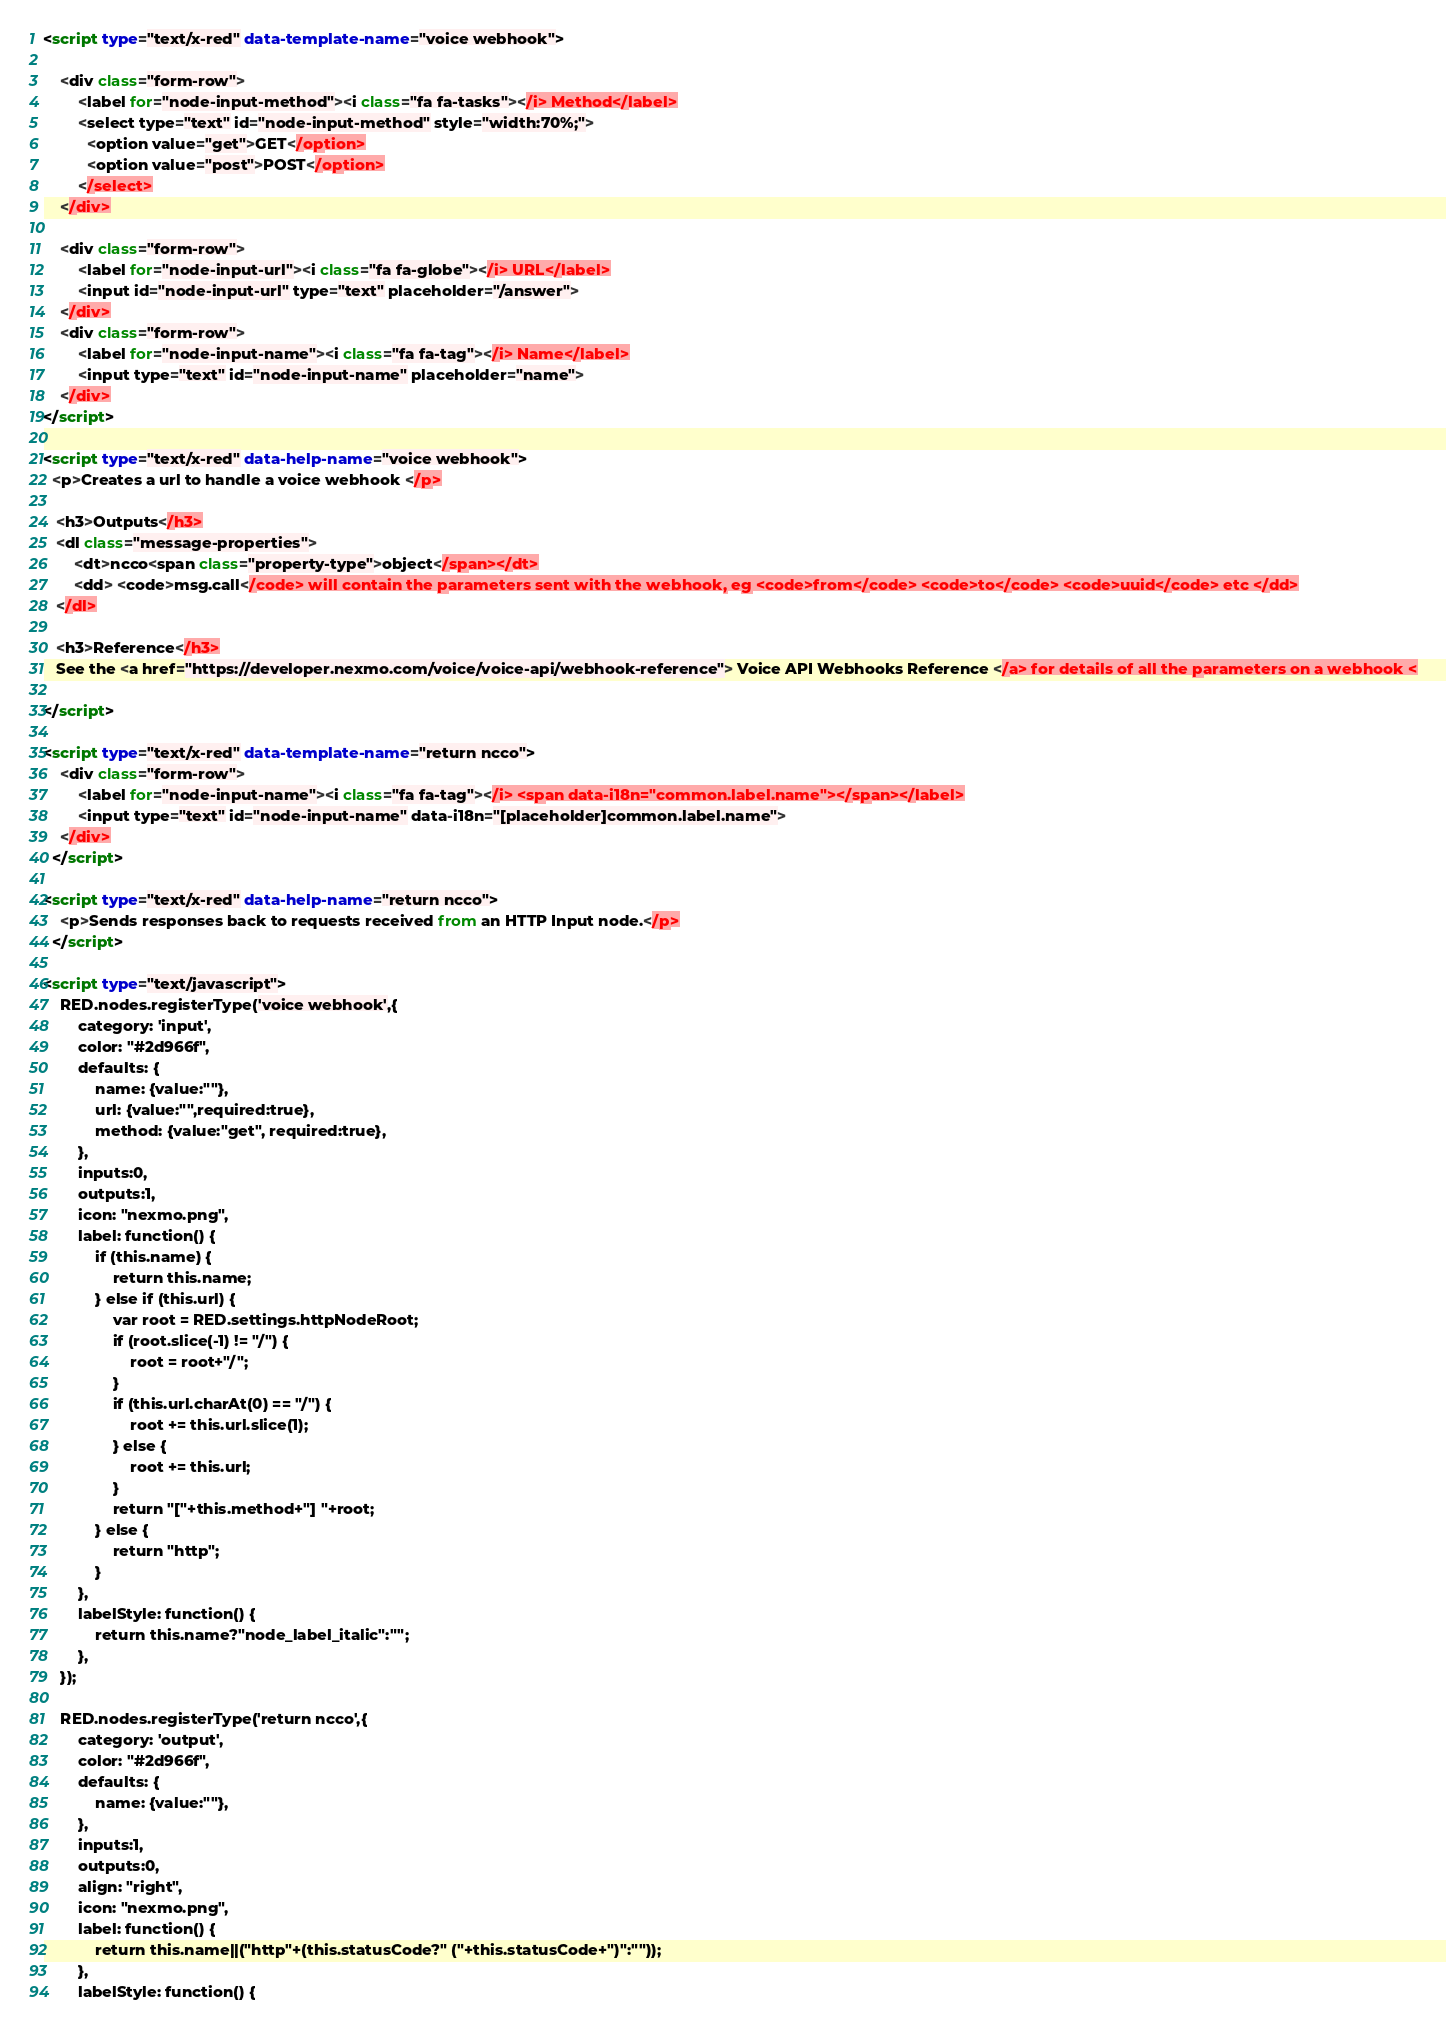Convert code to text. <code><loc_0><loc_0><loc_500><loc_500><_HTML_><script type="text/x-red" data-template-name="voice webhook">
   
    <div class="form-row">
        <label for="node-input-method"><i class="fa fa-tasks"></i> Method</label>
        <select type="text" id="node-input-method" style="width:70%;">
          <option value="get">GET</option>
          <option value="post">POST</option>
        </select>
    </div>

    <div class="form-row">
        <label for="node-input-url"><i class="fa fa-globe"></i> URL</label>
        <input id="node-input-url" type="text" placeholder="/answer">
    </div>
    <div class="form-row">
        <label for="node-input-name"><i class="fa fa-tag"></i> Name</label>
        <input type="text" id="node-input-name" placeholder="name">
    </div>
</script>

<script type="text/x-red" data-help-name="voice webhook">
  <p>Creates a url to handle a voice webhook </p>

   <h3>Outputs</h3>
   <dl class="message-properties">
       <dt>ncco<span class="property-type">object</span></dt>
       <dd> <code>msg.call</code> will contain the parameters sent with the webhook, eg <code>from</code> <code>to</code> <code>uuid</code> etc </dd>
   </dl>
   
   <h3>Reference</h3>
   See the <a href="https://developer.nexmo.com/voice/voice-api/webhook-reference"> Voice API Webhooks Reference </a> for details of all the parameters on a webhook <
   
</script>

<script type="text/x-red" data-template-name="return ncco">
    <div class="form-row">
        <label for="node-input-name"><i class="fa fa-tag"></i> <span data-i18n="common.label.name"></span></label>
        <input type="text" id="node-input-name" data-i18n="[placeholder]common.label.name">
    </div>
  </script>

<script type="text/x-red" data-help-name="return ncco">
    <p>Sends responses back to requests received from an HTTP Input node.</p>
  </script>

<script type="text/javascript">
    RED.nodes.registerType('voice webhook',{
        category: 'input',
        color: "#2d966f",
        defaults: {
            name: {value:""},
            url: {value:"",required:true},
            method: {value:"get", required:true},
        },
        inputs:0,
        outputs:1,
        icon: "nexmo.png",
        label: function() {
            if (this.name) {
                return this.name;
            } else if (this.url) {
                var root = RED.settings.httpNodeRoot;
                if (root.slice(-1) != "/") {
                    root = root+"/";
                }
                if (this.url.charAt(0) == "/") {
                    root += this.url.slice(1);
                } else {
                    root += this.url;
                }
                return "["+this.method+"] "+root;
            } else {
                return "http";
            }
        },
        labelStyle: function() {
            return this.name?"node_label_italic":"";
        },
    });

    RED.nodes.registerType('return ncco',{
        category: 'output',
        color: "#2d966f",
        defaults: {
            name: {value:""},
        },
        inputs:1,
        outputs:0,
        align: "right",
        icon: "nexmo.png",
        label: function() {
            return this.name||("http"+(this.statusCode?" ("+this.statusCode+")":""));
        },
        labelStyle: function() {</code> 